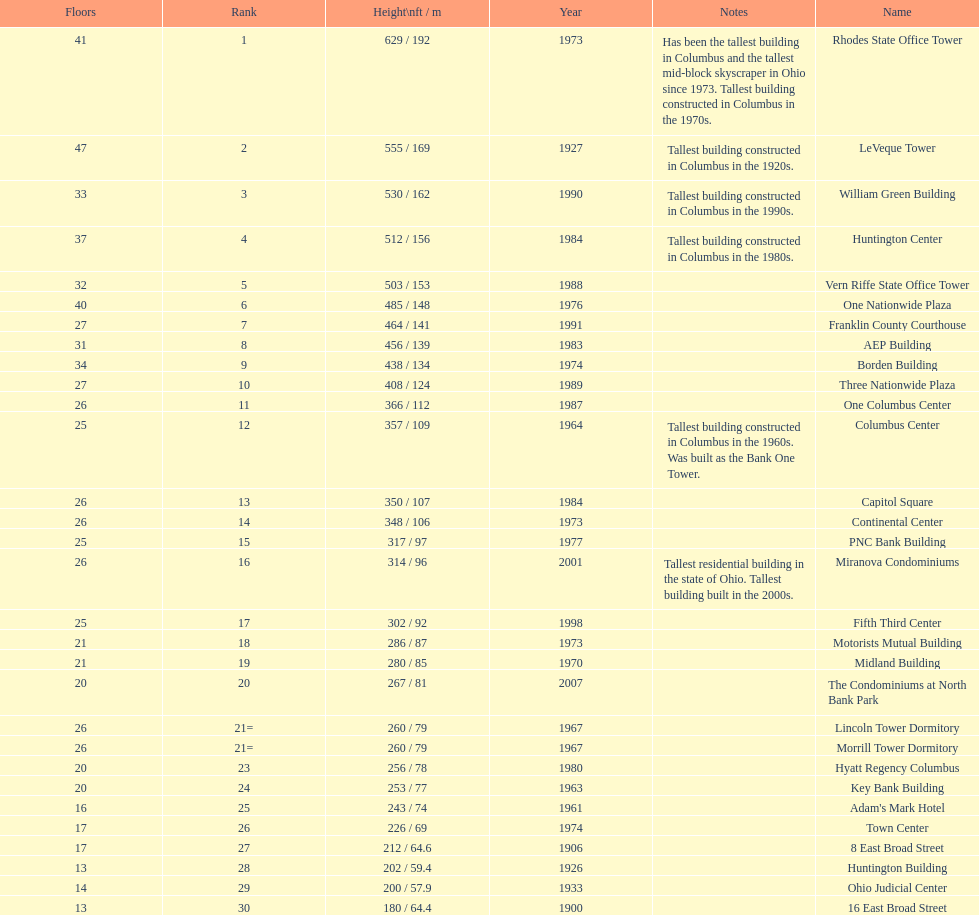Which is taller, the aep building or the one columbus center? AEP Building. Would you mind parsing the complete table? {'header': ['Floors', 'Rank', 'Height\\nft / m', 'Year', 'Notes', 'Name'], 'rows': [['41', '1', '629 / 192', '1973', 'Has been the tallest building in Columbus and the tallest mid-block skyscraper in Ohio since 1973. Tallest building constructed in Columbus in the 1970s.', 'Rhodes State Office Tower'], ['47', '2', '555 / 169', '1927', 'Tallest building constructed in Columbus in the 1920s.', 'LeVeque Tower'], ['33', '3', '530 / 162', '1990', 'Tallest building constructed in Columbus in the 1990s.', 'William Green Building'], ['37', '4', '512 / 156', '1984', 'Tallest building constructed in Columbus in the 1980s.', 'Huntington Center'], ['32', '5', '503 / 153', '1988', '', 'Vern Riffe State Office Tower'], ['40', '6', '485 / 148', '1976', '', 'One Nationwide Plaza'], ['27', '7', '464 / 141', '1991', '', 'Franklin County Courthouse'], ['31', '8', '456 / 139', '1983', '', 'AEP Building'], ['34', '9', '438 / 134', '1974', '', 'Borden Building'], ['27', '10', '408 / 124', '1989', '', 'Three Nationwide Plaza'], ['26', '11', '366 / 112', '1987', '', 'One Columbus Center'], ['25', '12', '357 / 109', '1964', 'Tallest building constructed in Columbus in the 1960s. Was built as the Bank One Tower.', 'Columbus Center'], ['26', '13', '350 / 107', '1984', '', 'Capitol Square'], ['26', '14', '348 / 106', '1973', '', 'Continental Center'], ['25', '15', '317 / 97', '1977', '', 'PNC Bank Building'], ['26', '16', '314 / 96', '2001', 'Tallest residential building in the state of Ohio. Tallest building built in the 2000s.', 'Miranova Condominiums'], ['25', '17', '302 / 92', '1998', '', 'Fifth Third Center'], ['21', '18', '286 / 87', '1973', '', 'Motorists Mutual Building'], ['21', '19', '280 / 85', '1970', '', 'Midland Building'], ['20', '20', '267 / 81', '2007', '', 'The Condominiums at North Bank Park'], ['26', '21=', '260 / 79', '1967', '', 'Lincoln Tower Dormitory'], ['26', '21=', '260 / 79', '1967', '', 'Morrill Tower Dormitory'], ['20', '23', '256 / 78', '1980', '', 'Hyatt Regency Columbus'], ['20', '24', '253 / 77', '1963', '', 'Key Bank Building'], ['16', '25', '243 / 74', '1961', '', "Adam's Mark Hotel"], ['17', '26', '226 / 69', '1974', '', 'Town Center'], ['17', '27', '212 / 64.6', '1906', '', '8 East Broad Street'], ['13', '28', '202 / 59.4', '1926', '', 'Huntington Building'], ['14', '29', '200 / 57.9', '1933', '', 'Ohio Judicial Center'], ['13', '30', '180 / 64.4', '1900', '', '16 East Broad Street']]} 